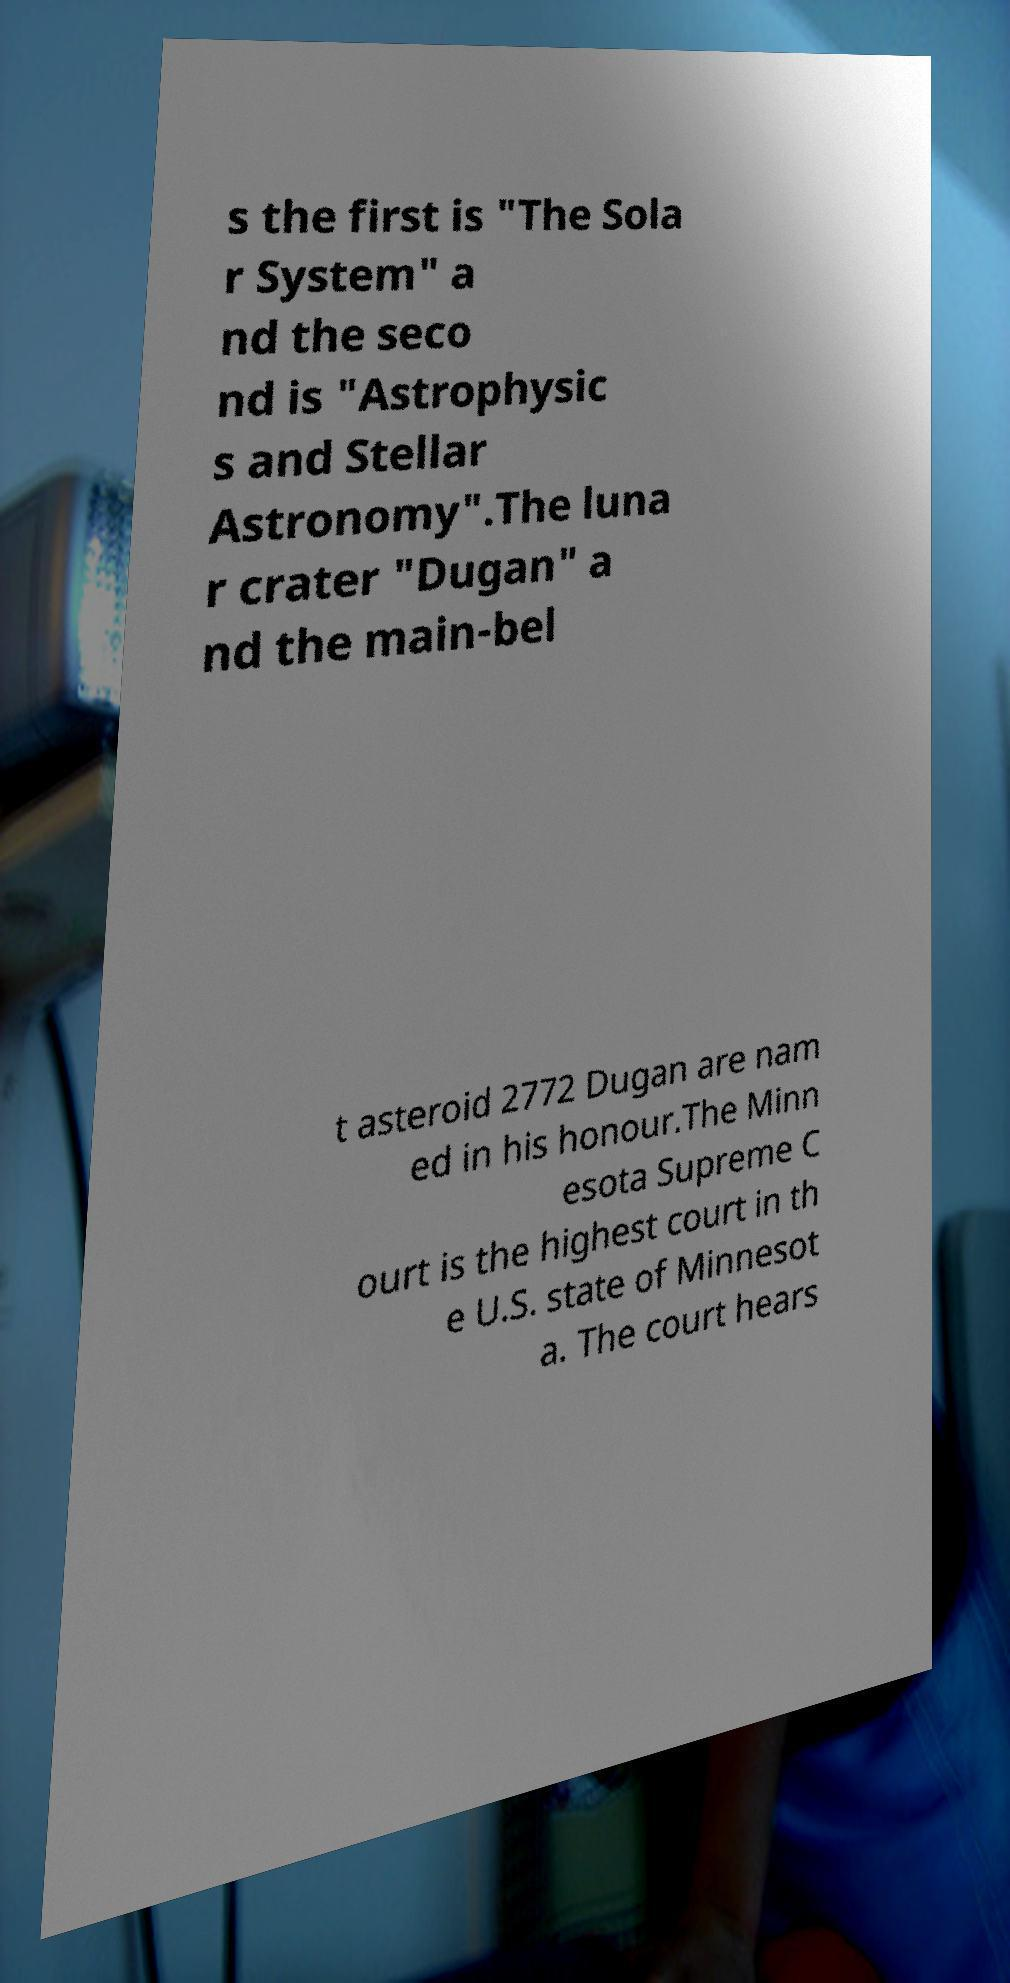Can you accurately transcribe the text from the provided image for me? s the first is "The Sola r System" a nd the seco nd is "Astrophysic s and Stellar Astronomy".The luna r crater "Dugan" a nd the main-bel t asteroid 2772 Dugan are nam ed in his honour.The Minn esota Supreme C ourt is the highest court in th e U.S. state of Minnesot a. The court hears 